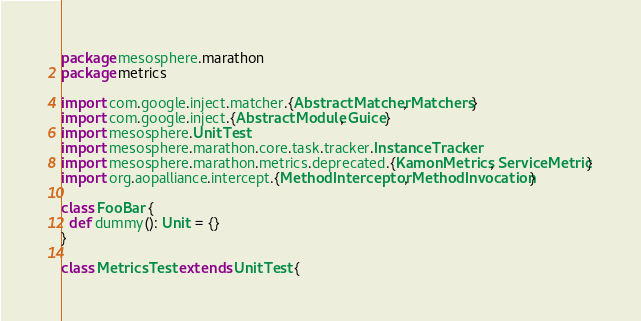<code> <loc_0><loc_0><loc_500><loc_500><_Scala_>package mesosphere.marathon
package metrics

import com.google.inject.matcher.{AbstractMatcher, Matchers}
import com.google.inject.{AbstractModule, Guice}
import mesosphere.UnitTest
import mesosphere.marathon.core.task.tracker.InstanceTracker
import mesosphere.marathon.metrics.deprecated.{KamonMetrics, ServiceMetric}
import org.aopalliance.intercept.{MethodInterceptor, MethodInvocation}

class FooBar {
  def dummy(): Unit = {}
}

class MetricsTest extends UnitTest {
</code> 